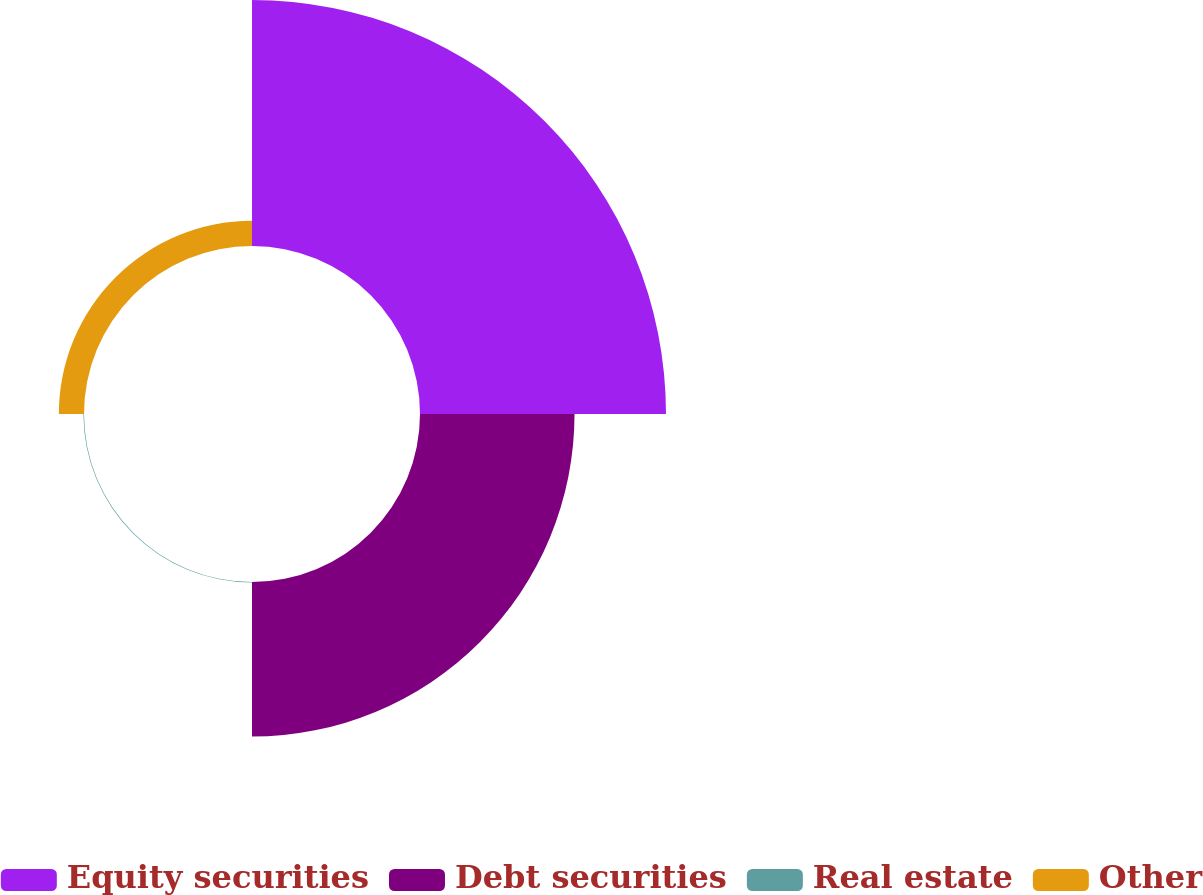Convert chart to OTSL. <chart><loc_0><loc_0><loc_500><loc_500><pie_chart><fcel>Equity securities<fcel>Debt securities<fcel>Real estate<fcel>Other<nl><fcel>57.71%<fcel>36.25%<fcel>0.14%<fcel>5.9%<nl></chart> 